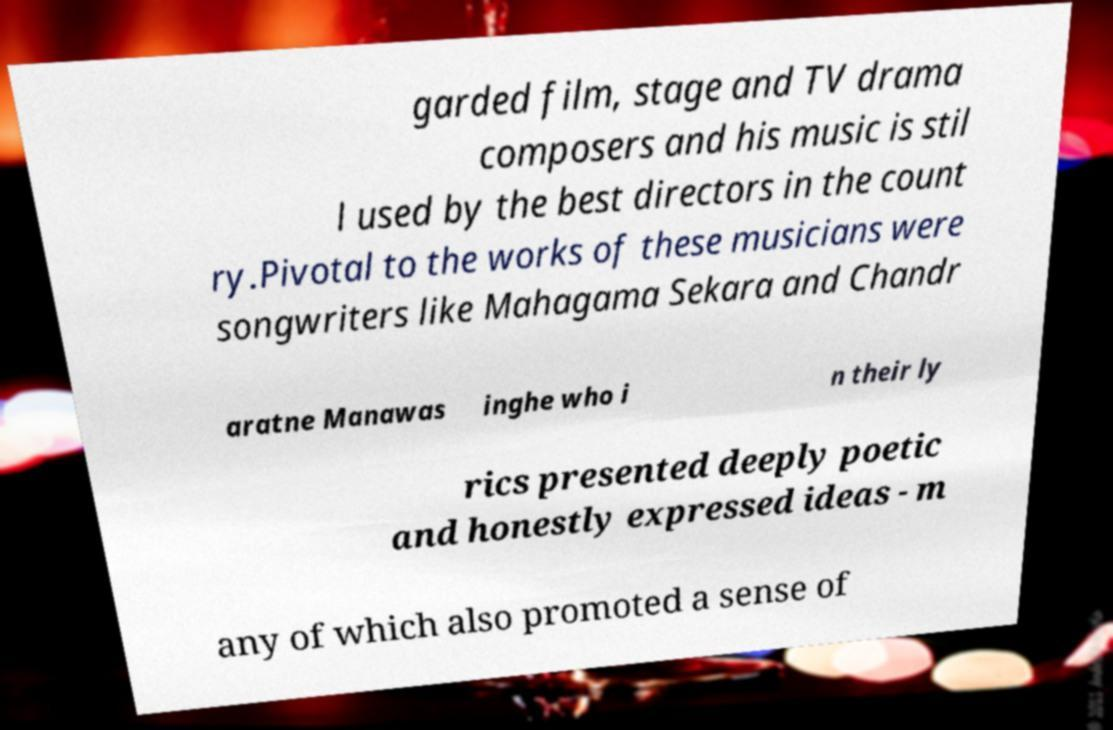For documentation purposes, I need the text within this image transcribed. Could you provide that? garded film, stage and TV drama composers and his music is stil l used by the best directors in the count ry.Pivotal to the works of these musicians were songwriters like Mahagama Sekara and Chandr aratne Manawas inghe who i n their ly rics presented deeply poetic and honestly expressed ideas - m any of which also promoted a sense of 